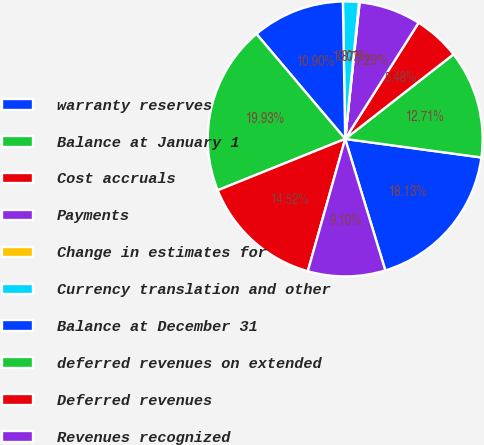<chart> <loc_0><loc_0><loc_500><loc_500><pie_chart><fcel>warranty reserves<fcel>Balance at January 1<fcel>Cost accruals<fcel>Payments<fcel>Change in estimates for<fcel>Currency translation and other<fcel>Balance at December 31<fcel>deferred revenues on extended<fcel>Deferred revenues<fcel>Revenues recognized<nl><fcel>18.13%<fcel>12.71%<fcel>5.48%<fcel>7.29%<fcel>0.07%<fcel>1.87%<fcel>10.9%<fcel>19.93%<fcel>14.52%<fcel>9.1%<nl></chart> 